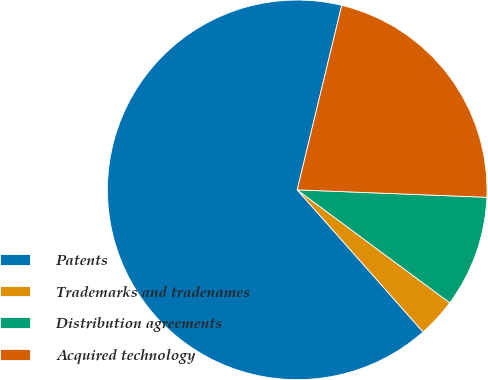Convert chart. <chart><loc_0><loc_0><loc_500><loc_500><pie_chart><fcel>Patents<fcel>Trademarks and tradenames<fcel>Distribution agreements<fcel>Acquired technology<nl><fcel>65.3%<fcel>3.32%<fcel>9.52%<fcel>21.85%<nl></chart> 